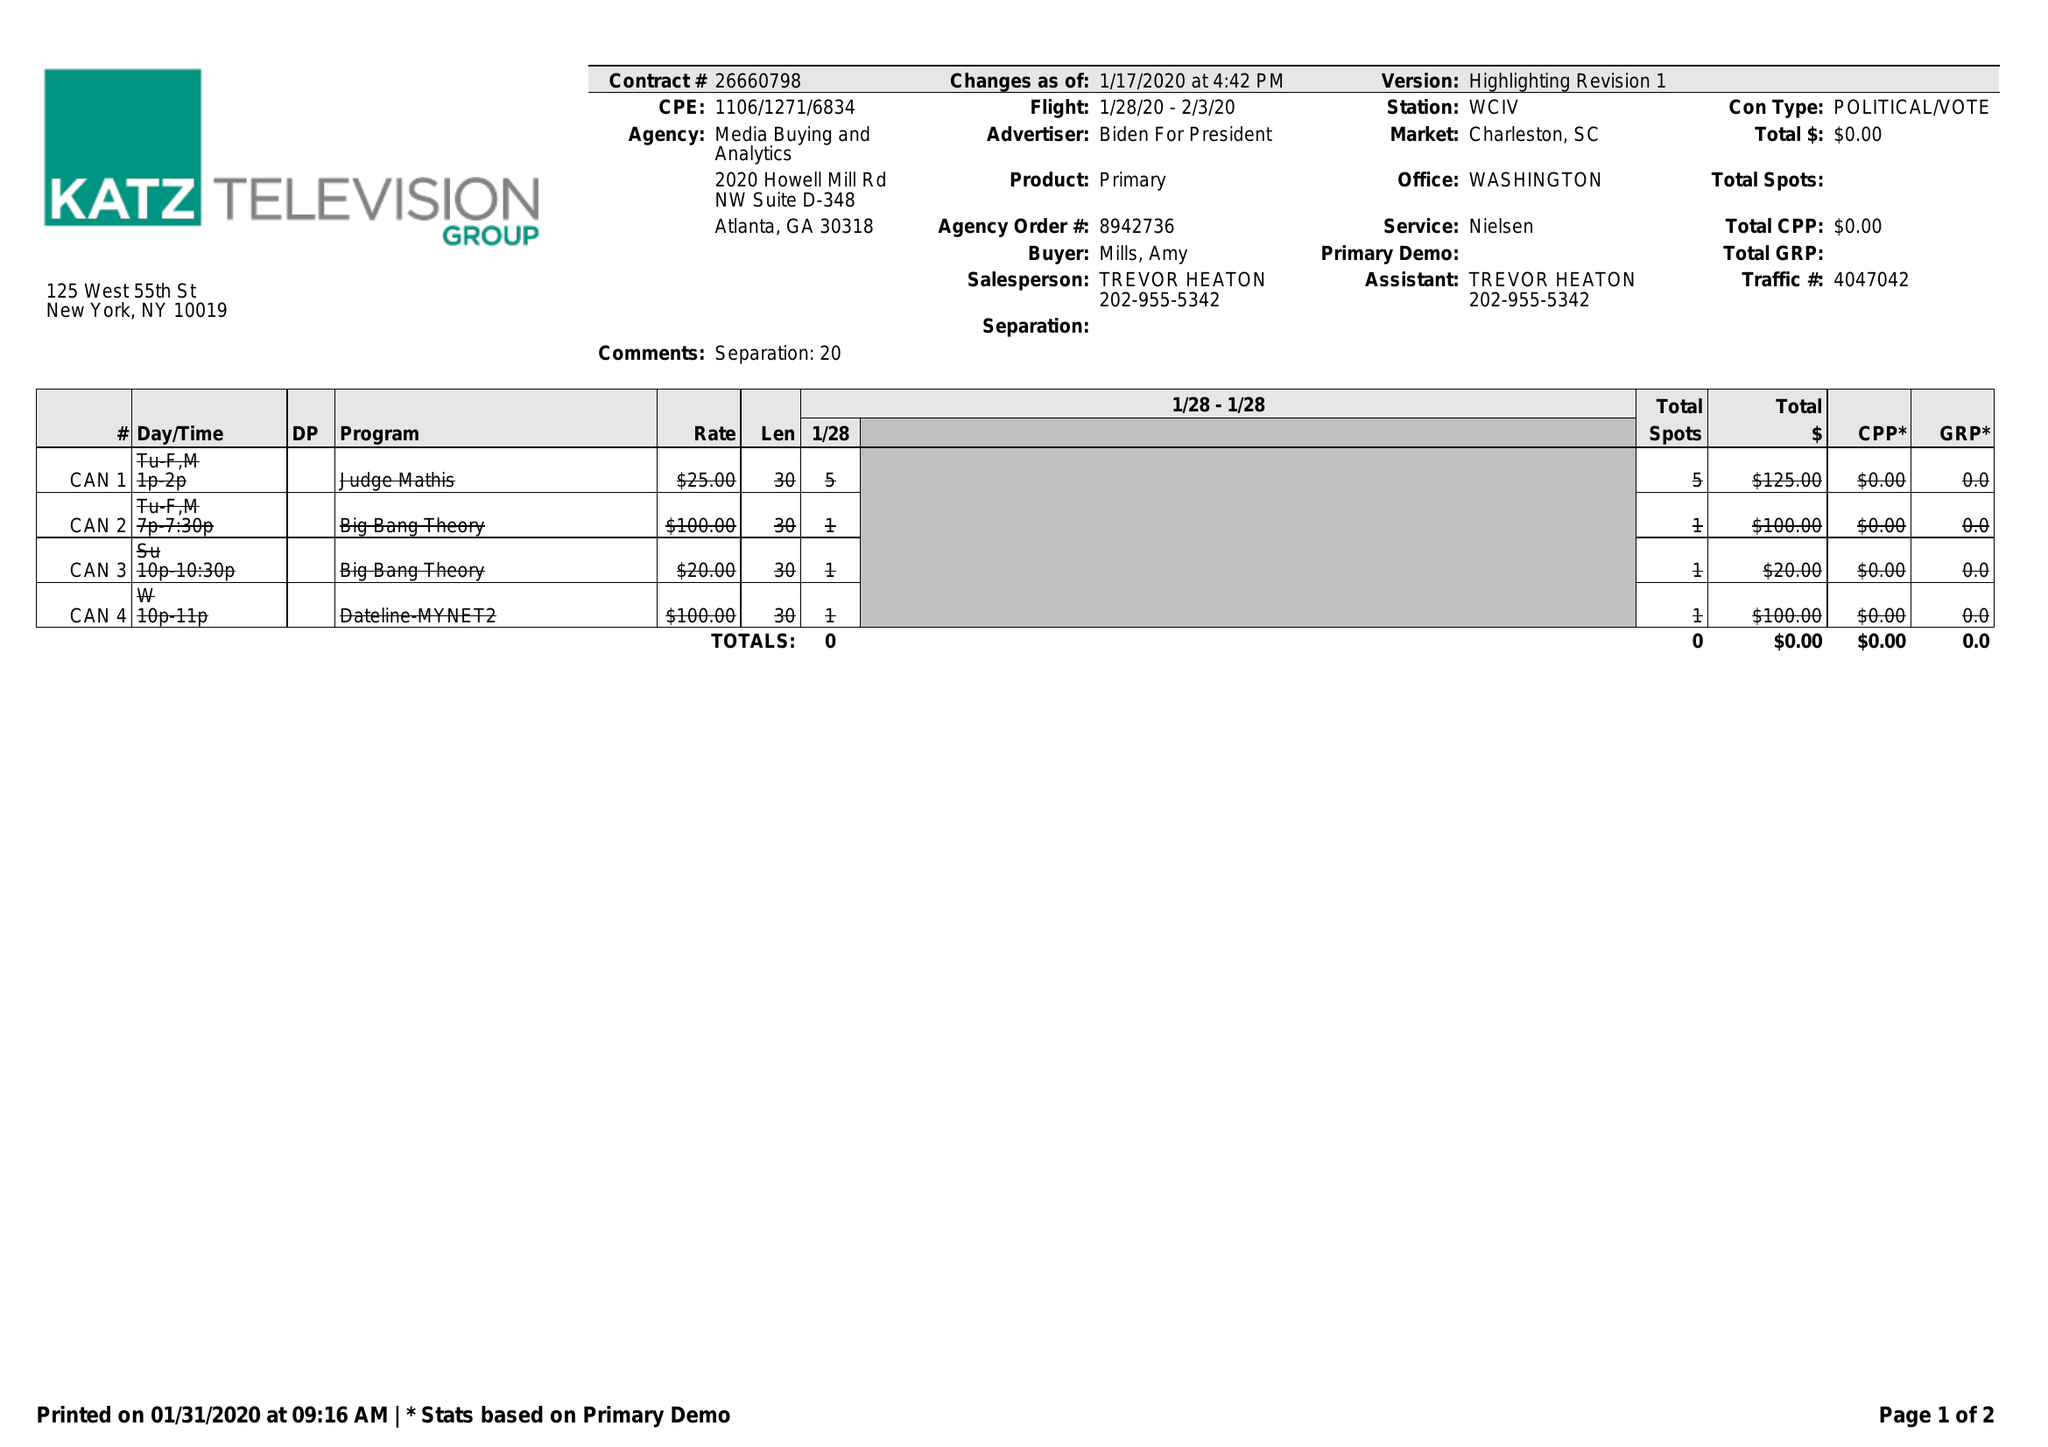What is the value for the flight_to?
Answer the question using a single word or phrase. 02/03/20 